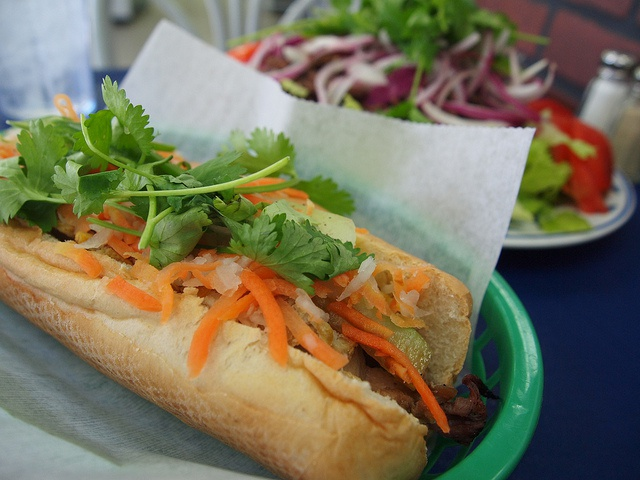Describe the objects in this image and their specific colors. I can see sandwich in darkgray, tan, olive, and brown tones, bowl in darkgray, black, green, and darkgreen tones, cup in darkgray, lightblue, and gray tones, carrot in darkgray, red, brown, and tan tones, and chair in darkgray and gray tones in this image. 